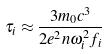<formula> <loc_0><loc_0><loc_500><loc_500>\tau _ { i } \approx \frac { 3 m _ { 0 } c ^ { 3 } } { 2 e ^ { 2 } n \omega _ { i } ^ { 2 } f _ { i } }</formula> 